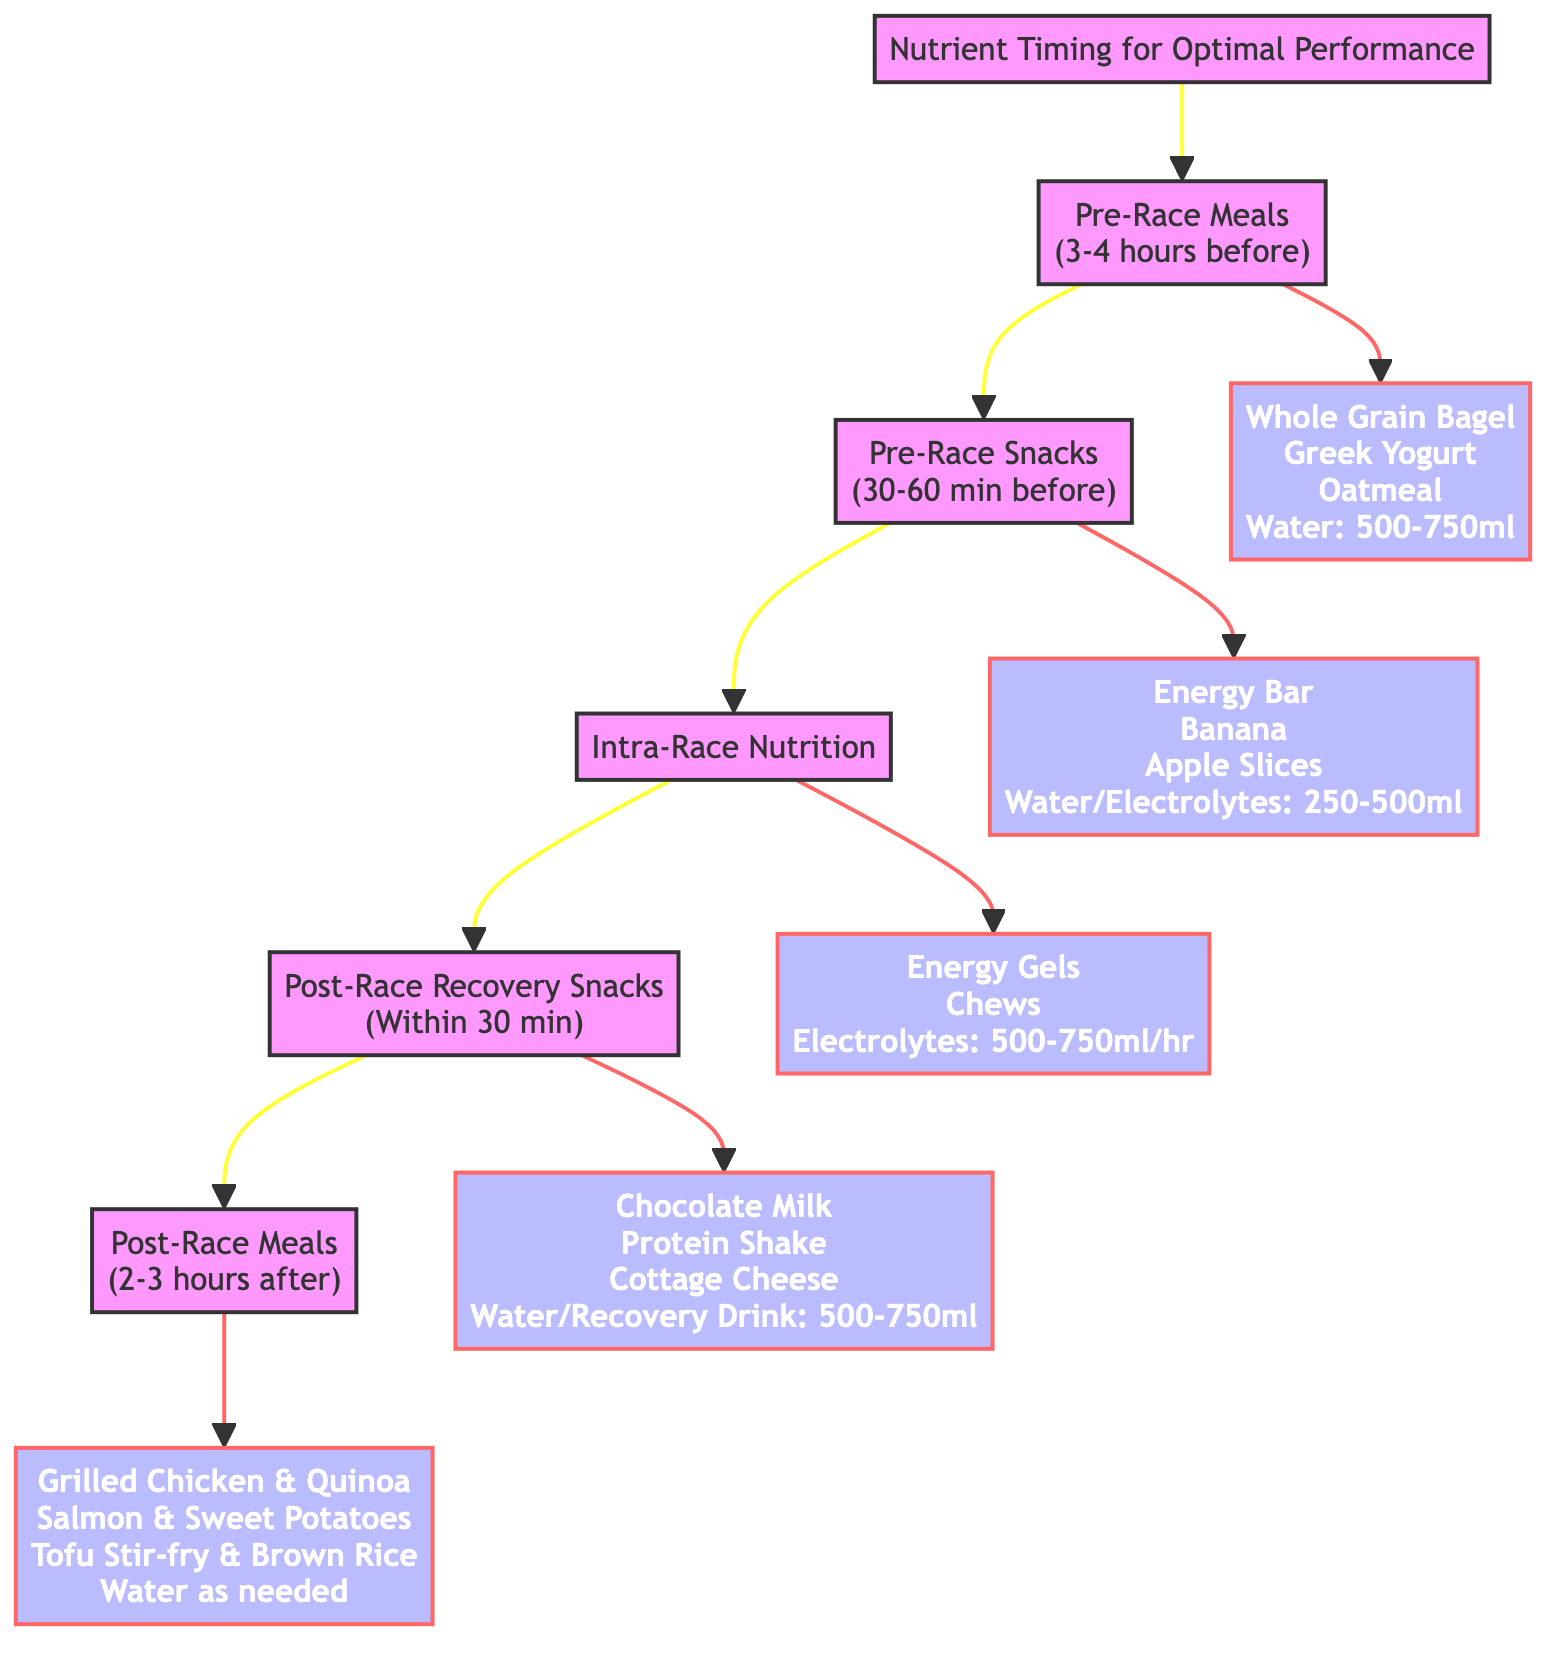What is the first step in the nutrient timing process? The diagram indicates that the first step is "Pre-Race Meals." This step is highlighted as the starting point of the flowchart.
Answer: Pre-Race Meals How long before the race should "Pre-Race Meals" be consumed? Looking at the details described in the "Pre-Race Meals" node, it states that these meals should be consumed "3-4 hours before race."
Answer: 3-4 hours before race What is one of the recommended components for "Post-Race Recovery Snacks"? Under the "Post-Race Recovery Snacks" step, it lists several components, including "Chocolate Milk," which is one of the recommended options.
Answer: Chocolate Milk What is the hydration recommendation during "Intra-Race Nutrition"? The "Intra-Race Nutrition" section specifies that hydration should include "500-750ml of electrolyte drink per hour," outlining the timing and amount needed.
Answer: 500-750ml of electrolyte drink per hour What are the two types of meals mentioned in the post-race section? In the flowchart, the post-race section is divided into two types: "Post-Race Recovery Snacks" and "Post-Race Meals," which are located at the end of the sequence.
Answer: Post-Race Recovery Snacks and Post-Race Meals How many components are listed for "Pre-Race Snacks"? Reviewing the "Pre-Race Snacks" node, there are four components listed under this step: "Energy Bar," "Banana," "Apple Slices with Almond Butter," and the hydration option, leading to a total of four.
Answer: Four What is the common hydration instruction mentioned in "Post-Race Meals"? The instruction under the "Post-Race Meals" indicates "Continue drinking water as needed," highlighting the ongoing need for hydration.
Answer: Continue drinking water as needed What is the relationship between "Pre-Race Meals" and "Pre-Race Snacks"? The flowchart visually depicts an arrow connecting "Pre-Race Meals" to "Pre-Race Snacks," showing that snacks are the next step after meals in the nutrient timing process.
Answer: Pre-Race Snacks follows Pre-Race Meals 